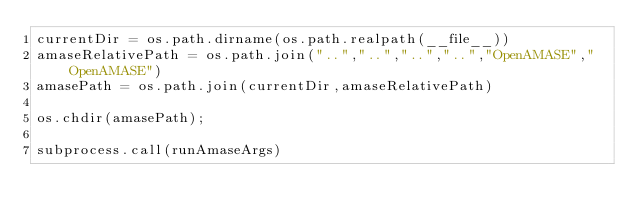<code> <loc_0><loc_0><loc_500><loc_500><_Python_>currentDir = os.path.dirname(os.path.realpath(__file__))
amaseRelativePath = os.path.join("..","..","..","..","OpenAMASE","OpenAMASE")
amasePath = os.path.join(currentDir,amaseRelativePath)

os.chdir(amasePath);

subprocess.call(runAmaseArgs)


</code> 